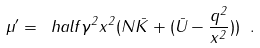Convert formula to latex. <formula><loc_0><loc_0><loc_500><loc_500>\mu ^ { \prime } = \ h a l f \gamma ^ { 2 } x ^ { 2 } ( N \bar { K } + ( \bar { U } - \frac { q ^ { 2 } } { x ^ { 2 } } ) ) \ .</formula> 